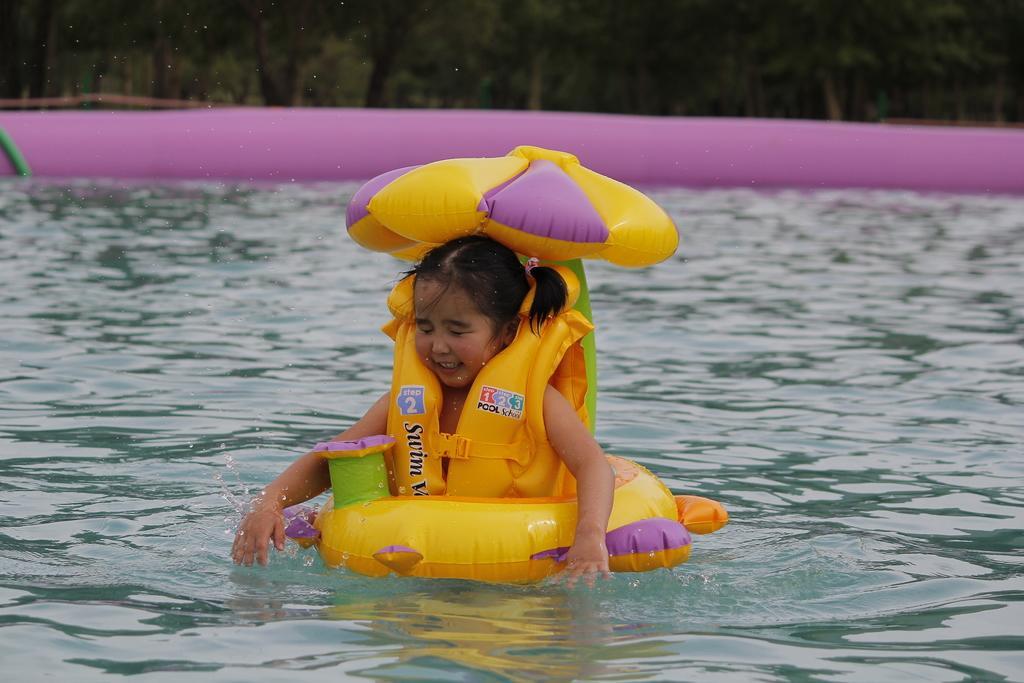Could you give a brief overview of what you see in this image? In the center of the image there is a girl swimming on the water with a balloon. In the background there is a water and trees. 